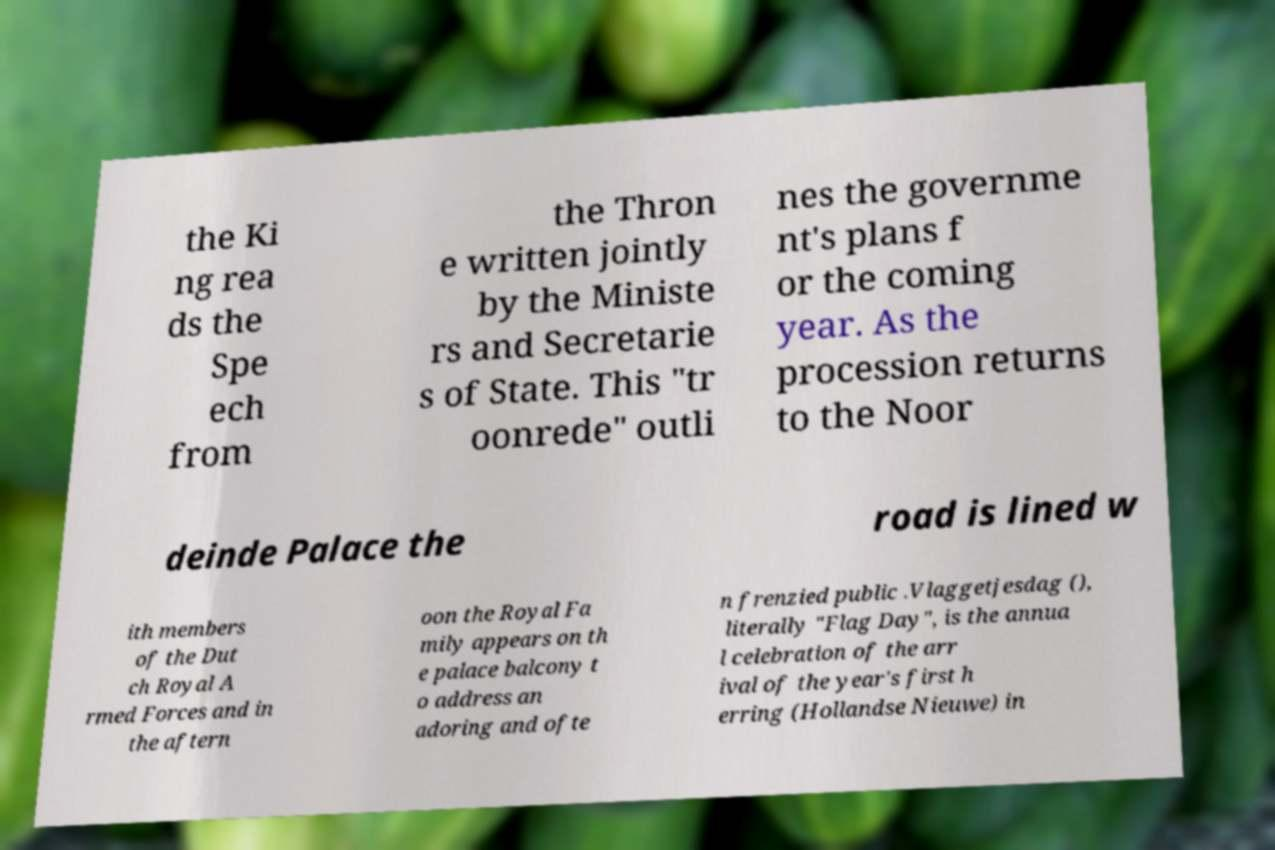What messages or text are displayed in this image? I need them in a readable, typed format. the Ki ng rea ds the Spe ech from the Thron e written jointly by the Ministe rs and Secretarie s of State. This "tr oonrede" outli nes the governme nt's plans f or the coming year. As the procession returns to the Noor deinde Palace the road is lined w ith members of the Dut ch Royal A rmed Forces and in the aftern oon the Royal Fa mily appears on th e palace balcony t o address an adoring and ofte n frenzied public .Vlaggetjesdag (), literally "Flag Day", is the annua l celebration of the arr ival of the year's first h erring (Hollandse Nieuwe) in 